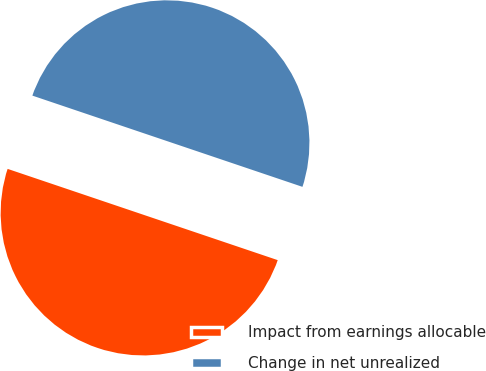Convert chart to OTSL. <chart><loc_0><loc_0><loc_500><loc_500><pie_chart><fcel>Impact from earnings allocable<fcel>Change in net unrealized<nl><fcel>50.0%<fcel>50.0%<nl></chart> 